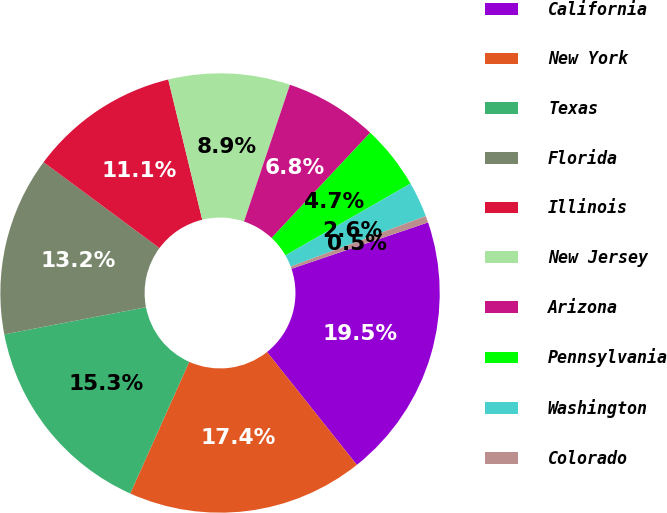<chart> <loc_0><loc_0><loc_500><loc_500><pie_chart><fcel>California<fcel>New York<fcel>Texas<fcel>Florida<fcel>Illinois<fcel>New Jersey<fcel>Arizona<fcel>Pennsylvania<fcel>Washington<fcel>Colorado<nl><fcel>19.51%<fcel>17.4%<fcel>15.28%<fcel>13.17%<fcel>11.06%<fcel>8.94%<fcel>6.83%<fcel>4.72%<fcel>2.6%<fcel>0.49%<nl></chart> 